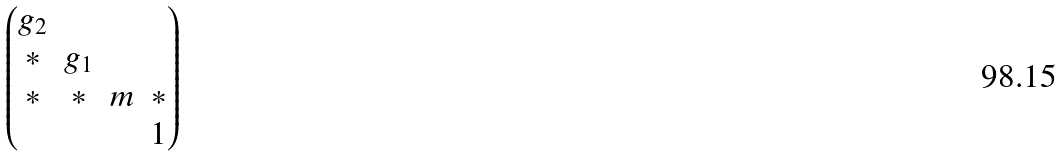Convert formula to latex. <formula><loc_0><loc_0><loc_500><loc_500>\begin{pmatrix} g _ { 2 } & & & \\ * & g _ { 1 } & & \\ * & * & m & * \\ & & & 1 \end{pmatrix}</formula> 